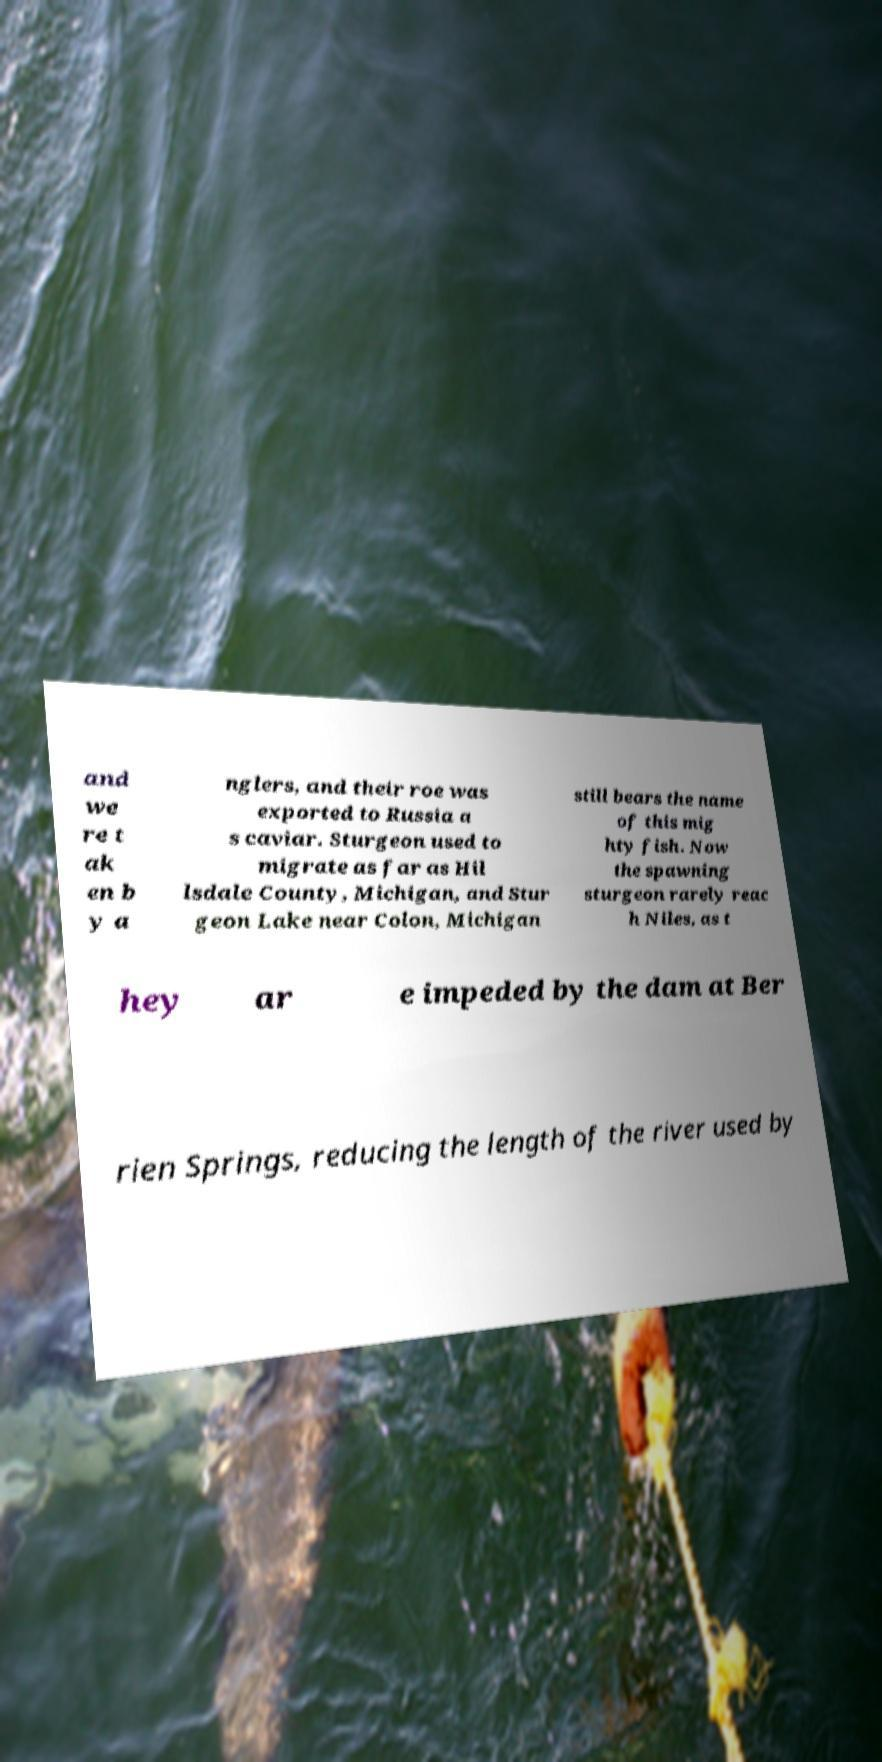For documentation purposes, I need the text within this image transcribed. Could you provide that? and we re t ak en b y a nglers, and their roe was exported to Russia a s caviar. Sturgeon used to migrate as far as Hil lsdale County, Michigan, and Stur geon Lake near Colon, Michigan still bears the name of this mig hty fish. Now the spawning sturgeon rarely reac h Niles, as t hey ar e impeded by the dam at Ber rien Springs, reducing the length of the river used by 